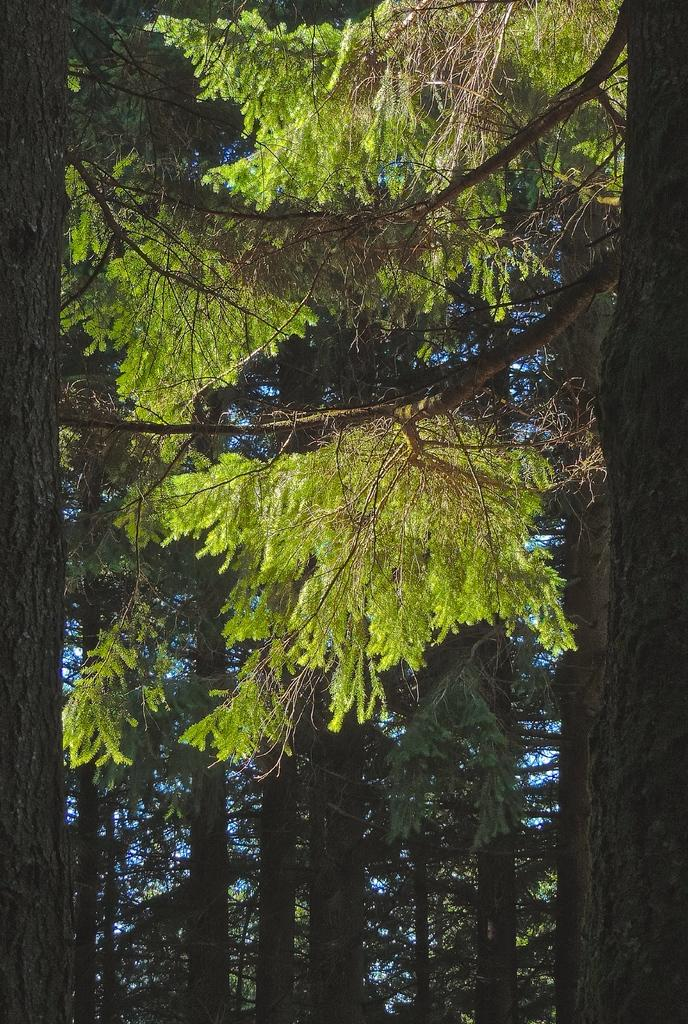What type of vegetation is at the bottom of the image? There are trees at the bottom of the image. What is the condition of the trees in the image? The trees have leaves on the ground. What can be seen in the background of the image? There are clouds in the background of the image. What color is the sky in the image? The sky is blue in the image. What type of industry can be seen in the image? There is no industry present in the image; it features trees, clouds, and a blue sky. What type of soda is being advertised on the table in the image? There is no table or soda present in the image. 